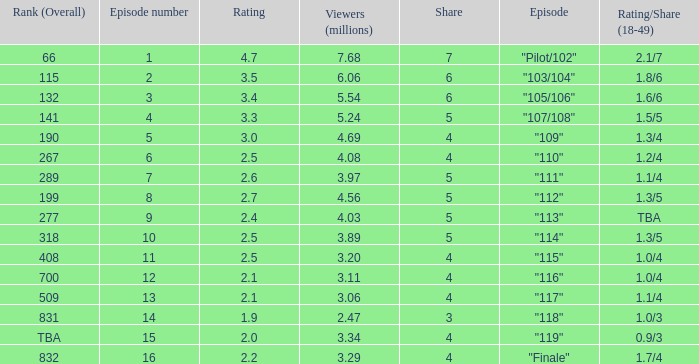WHAT IS THE HIGHEST VIEWERS WITH AN EPISODE LESS THAN 15 AND SHARE LAGER THAN 7? None. 